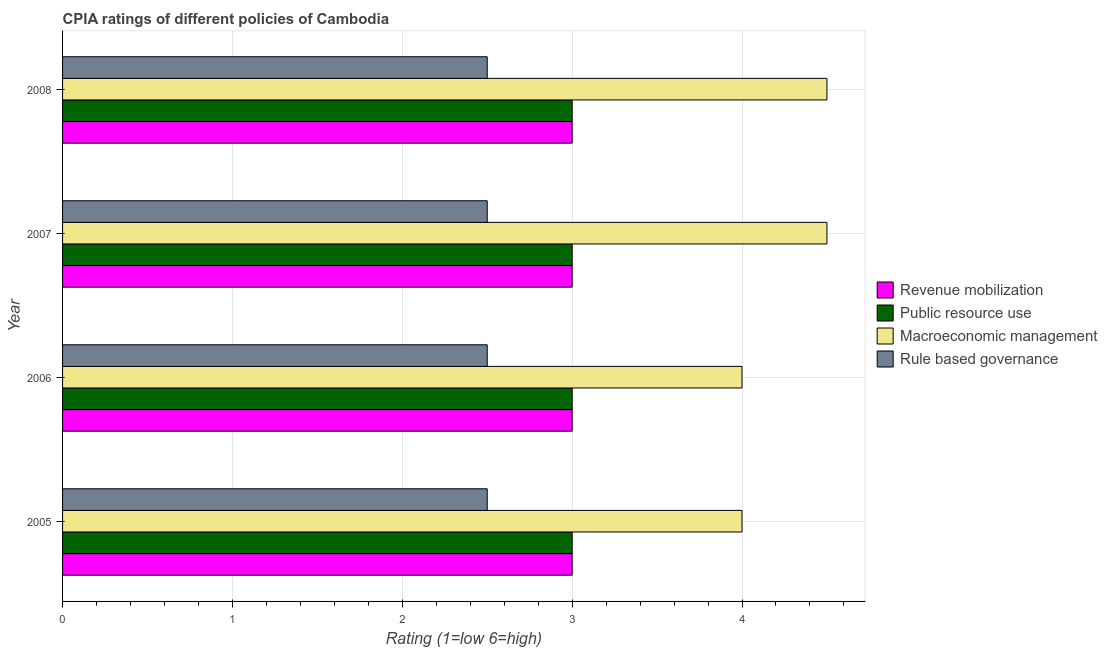How many different coloured bars are there?
Offer a very short reply. 4. What is the label of the 2nd group of bars from the top?
Provide a succinct answer. 2007. Across all years, what is the maximum cpia rating of macroeconomic management?
Make the answer very short. 4.5. In which year was the cpia rating of macroeconomic management minimum?
Your answer should be very brief. 2005. What is the difference between the cpia rating of rule based governance in 2007 and the cpia rating of revenue mobilization in 2008?
Offer a terse response. -0.5. What is the average cpia rating of revenue mobilization per year?
Ensure brevity in your answer.  3. In how many years, is the cpia rating of public resource use greater than 4.2 ?
Your response must be concise. 0. What is the ratio of the cpia rating of rule based governance in 2005 to that in 2006?
Ensure brevity in your answer.  1. Is the difference between the cpia rating of macroeconomic management in 2006 and 2008 greater than the difference between the cpia rating of rule based governance in 2006 and 2008?
Provide a short and direct response. No. What is the difference between the highest and the second highest cpia rating of macroeconomic management?
Provide a short and direct response. 0. In how many years, is the cpia rating of macroeconomic management greater than the average cpia rating of macroeconomic management taken over all years?
Your response must be concise. 2. Is the sum of the cpia rating of macroeconomic management in 2005 and 2006 greater than the maximum cpia rating of public resource use across all years?
Provide a succinct answer. Yes. Is it the case that in every year, the sum of the cpia rating of macroeconomic management and cpia rating of rule based governance is greater than the sum of cpia rating of public resource use and cpia rating of revenue mobilization?
Your response must be concise. Yes. What does the 3rd bar from the top in 2006 represents?
Your answer should be very brief. Public resource use. What does the 2nd bar from the bottom in 2005 represents?
Offer a very short reply. Public resource use. Is it the case that in every year, the sum of the cpia rating of revenue mobilization and cpia rating of public resource use is greater than the cpia rating of macroeconomic management?
Ensure brevity in your answer.  Yes. How many bars are there?
Keep it short and to the point. 16. How many years are there in the graph?
Your answer should be compact. 4. Are the values on the major ticks of X-axis written in scientific E-notation?
Provide a succinct answer. No. Does the graph contain grids?
Offer a very short reply. Yes. Where does the legend appear in the graph?
Your response must be concise. Center right. How many legend labels are there?
Give a very brief answer. 4. What is the title of the graph?
Keep it short and to the point. CPIA ratings of different policies of Cambodia. What is the label or title of the X-axis?
Ensure brevity in your answer.  Rating (1=low 6=high). What is the label or title of the Y-axis?
Offer a very short reply. Year. What is the Rating (1=low 6=high) of Rule based governance in 2005?
Your answer should be very brief. 2.5. What is the Rating (1=low 6=high) of Revenue mobilization in 2006?
Give a very brief answer. 3. What is the Rating (1=low 6=high) in Macroeconomic management in 2006?
Your answer should be very brief. 4. What is the Rating (1=low 6=high) in Rule based governance in 2006?
Provide a short and direct response. 2.5. What is the Rating (1=low 6=high) of Public resource use in 2007?
Your answer should be compact. 3. What is the Rating (1=low 6=high) in Rule based governance in 2007?
Provide a short and direct response. 2.5. What is the Rating (1=low 6=high) of Revenue mobilization in 2008?
Offer a very short reply. 3. What is the Rating (1=low 6=high) of Rule based governance in 2008?
Offer a terse response. 2.5. Across all years, what is the maximum Rating (1=low 6=high) of Revenue mobilization?
Provide a short and direct response. 3. Across all years, what is the maximum Rating (1=low 6=high) in Public resource use?
Make the answer very short. 3. Across all years, what is the maximum Rating (1=low 6=high) in Macroeconomic management?
Your answer should be compact. 4.5. What is the total Rating (1=low 6=high) in Revenue mobilization in the graph?
Offer a terse response. 12. What is the difference between the Rating (1=low 6=high) of Macroeconomic management in 2005 and that in 2006?
Your answer should be compact. 0. What is the difference between the Rating (1=low 6=high) in Rule based governance in 2005 and that in 2007?
Your answer should be very brief. 0. What is the difference between the Rating (1=low 6=high) in Revenue mobilization in 2005 and that in 2008?
Provide a succinct answer. 0. What is the difference between the Rating (1=low 6=high) of Rule based governance in 2005 and that in 2008?
Your answer should be compact. 0. What is the difference between the Rating (1=low 6=high) in Revenue mobilization in 2006 and that in 2007?
Offer a very short reply. 0. What is the difference between the Rating (1=low 6=high) of Revenue mobilization in 2006 and that in 2008?
Offer a terse response. 0. What is the difference between the Rating (1=low 6=high) in Public resource use in 2006 and that in 2008?
Offer a terse response. 0. What is the difference between the Rating (1=low 6=high) of Public resource use in 2007 and that in 2008?
Your answer should be compact. 0. What is the difference between the Rating (1=low 6=high) of Public resource use in 2005 and the Rating (1=low 6=high) of Rule based governance in 2006?
Make the answer very short. 0.5. What is the difference between the Rating (1=low 6=high) in Macroeconomic management in 2005 and the Rating (1=low 6=high) in Rule based governance in 2006?
Your answer should be compact. 1.5. What is the difference between the Rating (1=low 6=high) in Revenue mobilization in 2005 and the Rating (1=low 6=high) in Macroeconomic management in 2007?
Your answer should be compact. -1.5. What is the difference between the Rating (1=low 6=high) of Public resource use in 2005 and the Rating (1=low 6=high) of Rule based governance in 2007?
Your answer should be compact. 0.5. What is the difference between the Rating (1=low 6=high) of Macroeconomic management in 2005 and the Rating (1=low 6=high) of Rule based governance in 2007?
Provide a succinct answer. 1.5. What is the difference between the Rating (1=low 6=high) of Macroeconomic management in 2005 and the Rating (1=low 6=high) of Rule based governance in 2008?
Your response must be concise. 1.5. What is the difference between the Rating (1=low 6=high) in Revenue mobilization in 2006 and the Rating (1=low 6=high) in Public resource use in 2007?
Your answer should be very brief. 0. What is the difference between the Rating (1=low 6=high) in Revenue mobilization in 2006 and the Rating (1=low 6=high) in Macroeconomic management in 2007?
Give a very brief answer. -1.5. What is the difference between the Rating (1=low 6=high) in Revenue mobilization in 2006 and the Rating (1=low 6=high) in Rule based governance in 2007?
Provide a succinct answer. 0.5. What is the difference between the Rating (1=low 6=high) in Public resource use in 2006 and the Rating (1=low 6=high) in Macroeconomic management in 2007?
Offer a very short reply. -1.5. What is the difference between the Rating (1=low 6=high) of Public resource use in 2006 and the Rating (1=low 6=high) of Rule based governance in 2007?
Offer a terse response. 0.5. What is the difference between the Rating (1=low 6=high) in Revenue mobilization in 2006 and the Rating (1=low 6=high) in Public resource use in 2008?
Ensure brevity in your answer.  0. What is the difference between the Rating (1=low 6=high) in Revenue mobilization in 2006 and the Rating (1=low 6=high) in Rule based governance in 2008?
Your response must be concise. 0.5. What is the difference between the Rating (1=low 6=high) of Public resource use in 2006 and the Rating (1=low 6=high) of Macroeconomic management in 2008?
Provide a short and direct response. -1.5. What is the difference between the Rating (1=low 6=high) in Public resource use in 2006 and the Rating (1=low 6=high) in Rule based governance in 2008?
Offer a very short reply. 0.5. What is the difference between the Rating (1=low 6=high) in Public resource use in 2007 and the Rating (1=low 6=high) in Macroeconomic management in 2008?
Provide a succinct answer. -1.5. What is the average Rating (1=low 6=high) of Macroeconomic management per year?
Keep it short and to the point. 4.25. What is the average Rating (1=low 6=high) in Rule based governance per year?
Provide a succinct answer. 2.5. In the year 2005, what is the difference between the Rating (1=low 6=high) in Revenue mobilization and Rating (1=low 6=high) in Public resource use?
Keep it short and to the point. 0. In the year 2005, what is the difference between the Rating (1=low 6=high) of Macroeconomic management and Rating (1=low 6=high) of Rule based governance?
Provide a short and direct response. 1.5. In the year 2006, what is the difference between the Rating (1=low 6=high) in Revenue mobilization and Rating (1=low 6=high) in Public resource use?
Provide a succinct answer. 0. In the year 2006, what is the difference between the Rating (1=low 6=high) in Revenue mobilization and Rating (1=low 6=high) in Macroeconomic management?
Provide a succinct answer. -1. In the year 2006, what is the difference between the Rating (1=low 6=high) in Public resource use and Rating (1=low 6=high) in Rule based governance?
Provide a succinct answer. 0.5. In the year 2006, what is the difference between the Rating (1=low 6=high) in Macroeconomic management and Rating (1=low 6=high) in Rule based governance?
Give a very brief answer. 1.5. In the year 2007, what is the difference between the Rating (1=low 6=high) in Revenue mobilization and Rating (1=low 6=high) in Public resource use?
Make the answer very short. 0. In the year 2007, what is the difference between the Rating (1=low 6=high) in Revenue mobilization and Rating (1=low 6=high) in Macroeconomic management?
Offer a terse response. -1.5. In the year 2007, what is the difference between the Rating (1=low 6=high) of Public resource use and Rating (1=low 6=high) of Macroeconomic management?
Ensure brevity in your answer.  -1.5. In the year 2007, what is the difference between the Rating (1=low 6=high) in Macroeconomic management and Rating (1=low 6=high) in Rule based governance?
Ensure brevity in your answer.  2. In the year 2008, what is the difference between the Rating (1=low 6=high) in Revenue mobilization and Rating (1=low 6=high) in Macroeconomic management?
Offer a terse response. -1.5. In the year 2008, what is the difference between the Rating (1=low 6=high) in Revenue mobilization and Rating (1=low 6=high) in Rule based governance?
Your answer should be compact. 0.5. In the year 2008, what is the difference between the Rating (1=low 6=high) of Public resource use and Rating (1=low 6=high) of Macroeconomic management?
Provide a succinct answer. -1.5. In the year 2008, what is the difference between the Rating (1=low 6=high) of Macroeconomic management and Rating (1=low 6=high) of Rule based governance?
Your answer should be compact. 2. What is the ratio of the Rating (1=low 6=high) of Public resource use in 2005 to that in 2006?
Give a very brief answer. 1. What is the ratio of the Rating (1=low 6=high) of Rule based governance in 2005 to that in 2006?
Provide a short and direct response. 1. What is the ratio of the Rating (1=low 6=high) in Macroeconomic management in 2005 to that in 2007?
Make the answer very short. 0.89. What is the ratio of the Rating (1=low 6=high) of Revenue mobilization in 2005 to that in 2008?
Ensure brevity in your answer.  1. What is the ratio of the Rating (1=low 6=high) in Rule based governance in 2005 to that in 2008?
Keep it short and to the point. 1. What is the ratio of the Rating (1=low 6=high) in Revenue mobilization in 2006 to that in 2007?
Make the answer very short. 1. What is the ratio of the Rating (1=low 6=high) in Public resource use in 2006 to that in 2007?
Make the answer very short. 1. What is the ratio of the Rating (1=low 6=high) of Revenue mobilization in 2006 to that in 2008?
Give a very brief answer. 1. What is the ratio of the Rating (1=low 6=high) in Public resource use in 2006 to that in 2008?
Your answer should be very brief. 1. What is the ratio of the Rating (1=low 6=high) in Macroeconomic management in 2006 to that in 2008?
Keep it short and to the point. 0.89. What is the ratio of the Rating (1=low 6=high) in Rule based governance in 2006 to that in 2008?
Provide a succinct answer. 1. What is the ratio of the Rating (1=low 6=high) in Revenue mobilization in 2007 to that in 2008?
Make the answer very short. 1. What is the ratio of the Rating (1=low 6=high) of Public resource use in 2007 to that in 2008?
Ensure brevity in your answer.  1. What is the ratio of the Rating (1=low 6=high) in Macroeconomic management in 2007 to that in 2008?
Your answer should be very brief. 1. What is the ratio of the Rating (1=low 6=high) of Rule based governance in 2007 to that in 2008?
Your answer should be very brief. 1. What is the difference between the highest and the second highest Rating (1=low 6=high) in Revenue mobilization?
Ensure brevity in your answer.  0. 